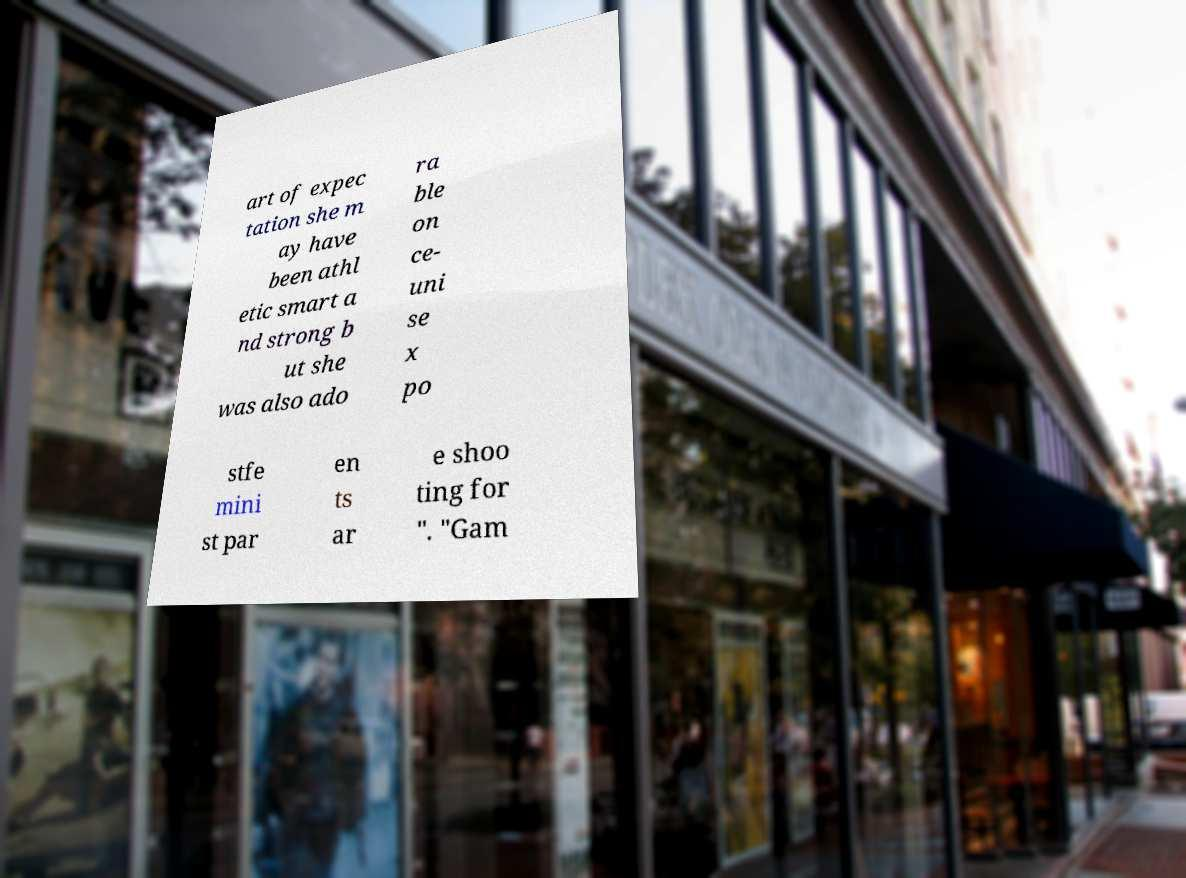Could you extract and type out the text from this image? art of expec tation she m ay have been athl etic smart a nd strong b ut she was also ado ra ble on ce- uni se x po stfe mini st par en ts ar e shoo ting for ". "Gam 